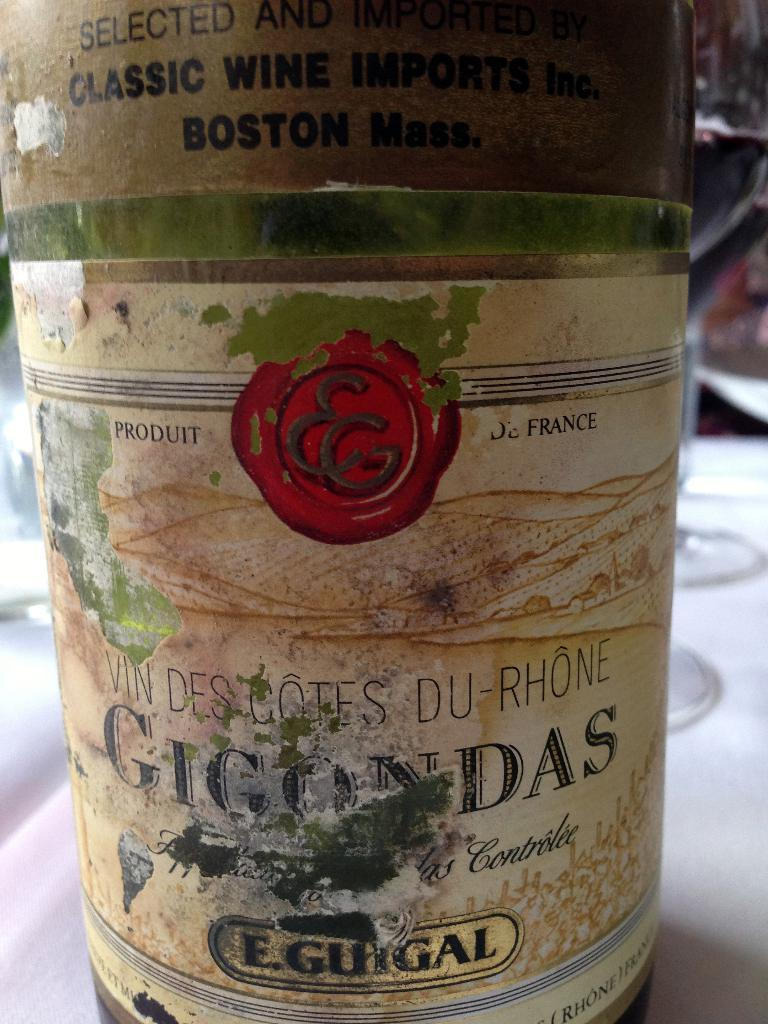Provide a one-sentence caption for the provided image. A label of an old wine bottle is shown with a sticker saying Classic wine imports on top. 